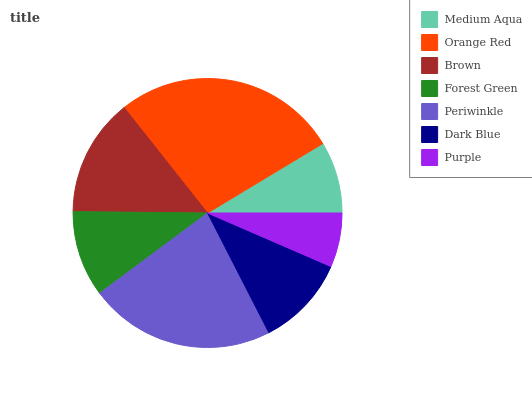Is Purple the minimum?
Answer yes or no. Yes. Is Orange Red the maximum?
Answer yes or no. Yes. Is Brown the minimum?
Answer yes or no. No. Is Brown the maximum?
Answer yes or no. No. Is Orange Red greater than Brown?
Answer yes or no. Yes. Is Brown less than Orange Red?
Answer yes or no. Yes. Is Brown greater than Orange Red?
Answer yes or no. No. Is Orange Red less than Brown?
Answer yes or no. No. Is Dark Blue the high median?
Answer yes or no. Yes. Is Dark Blue the low median?
Answer yes or no. Yes. Is Periwinkle the high median?
Answer yes or no. No. Is Orange Red the low median?
Answer yes or no. No. 